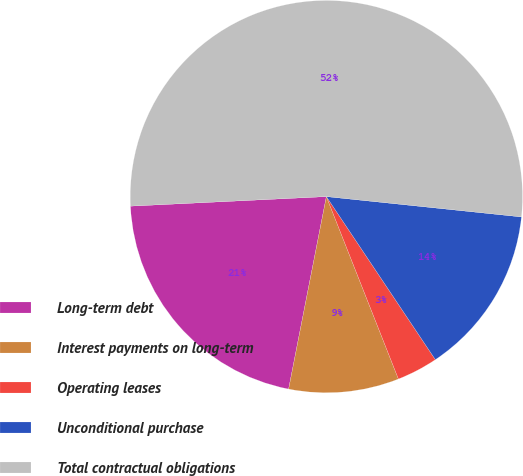<chart> <loc_0><loc_0><loc_500><loc_500><pie_chart><fcel>Long-term debt<fcel>Interest payments on long-term<fcel>Operating leases<fcel>Unconditional purchase<fcel>Total contractual obligations<nl><fcel>21.14%<fcel>9.07%<fcel>3.39%<fcel>13.97%<fcel>52.43%<nl></chart> 